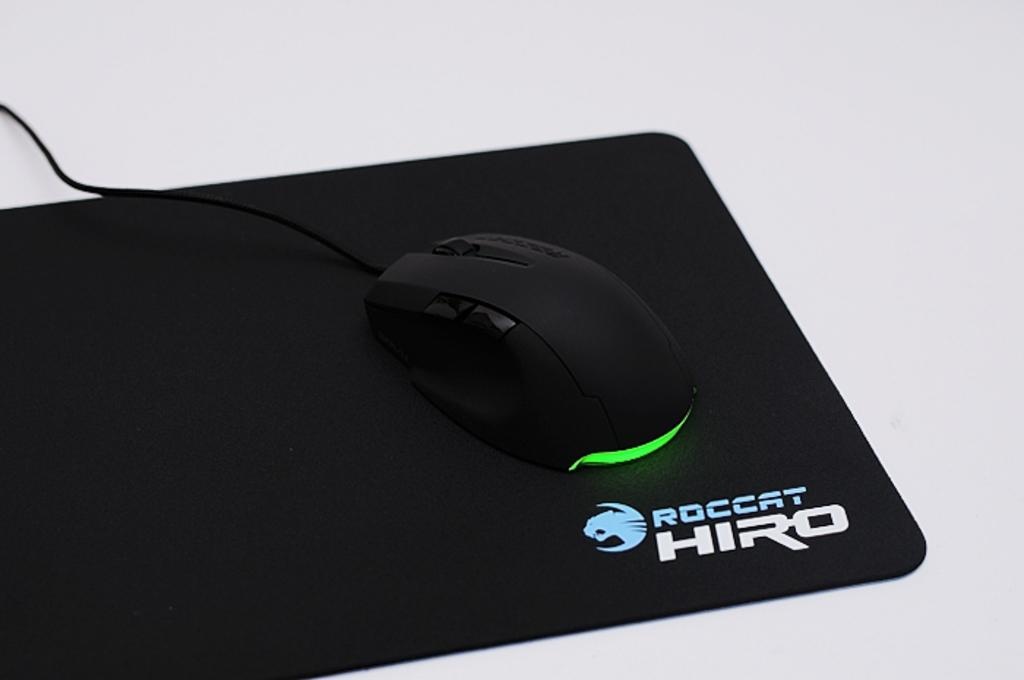What electronic device is visible in the image? There is a laptop in the image. What color is the laptop? The laptop is black in color. What accessory is also visible in the image? There is a mouse in the image. What color is the mouse? The mouse is black in color. What is the color of the surface on which the laptop and mouse are placed? The laptop and mouse are on a white surface. How many times does the cent appear in the image? There is no cent present in the image. What type of selection is being made in the image? There is no selection being made in the image; it simply shows a laptop and a mouse on a white surface. 